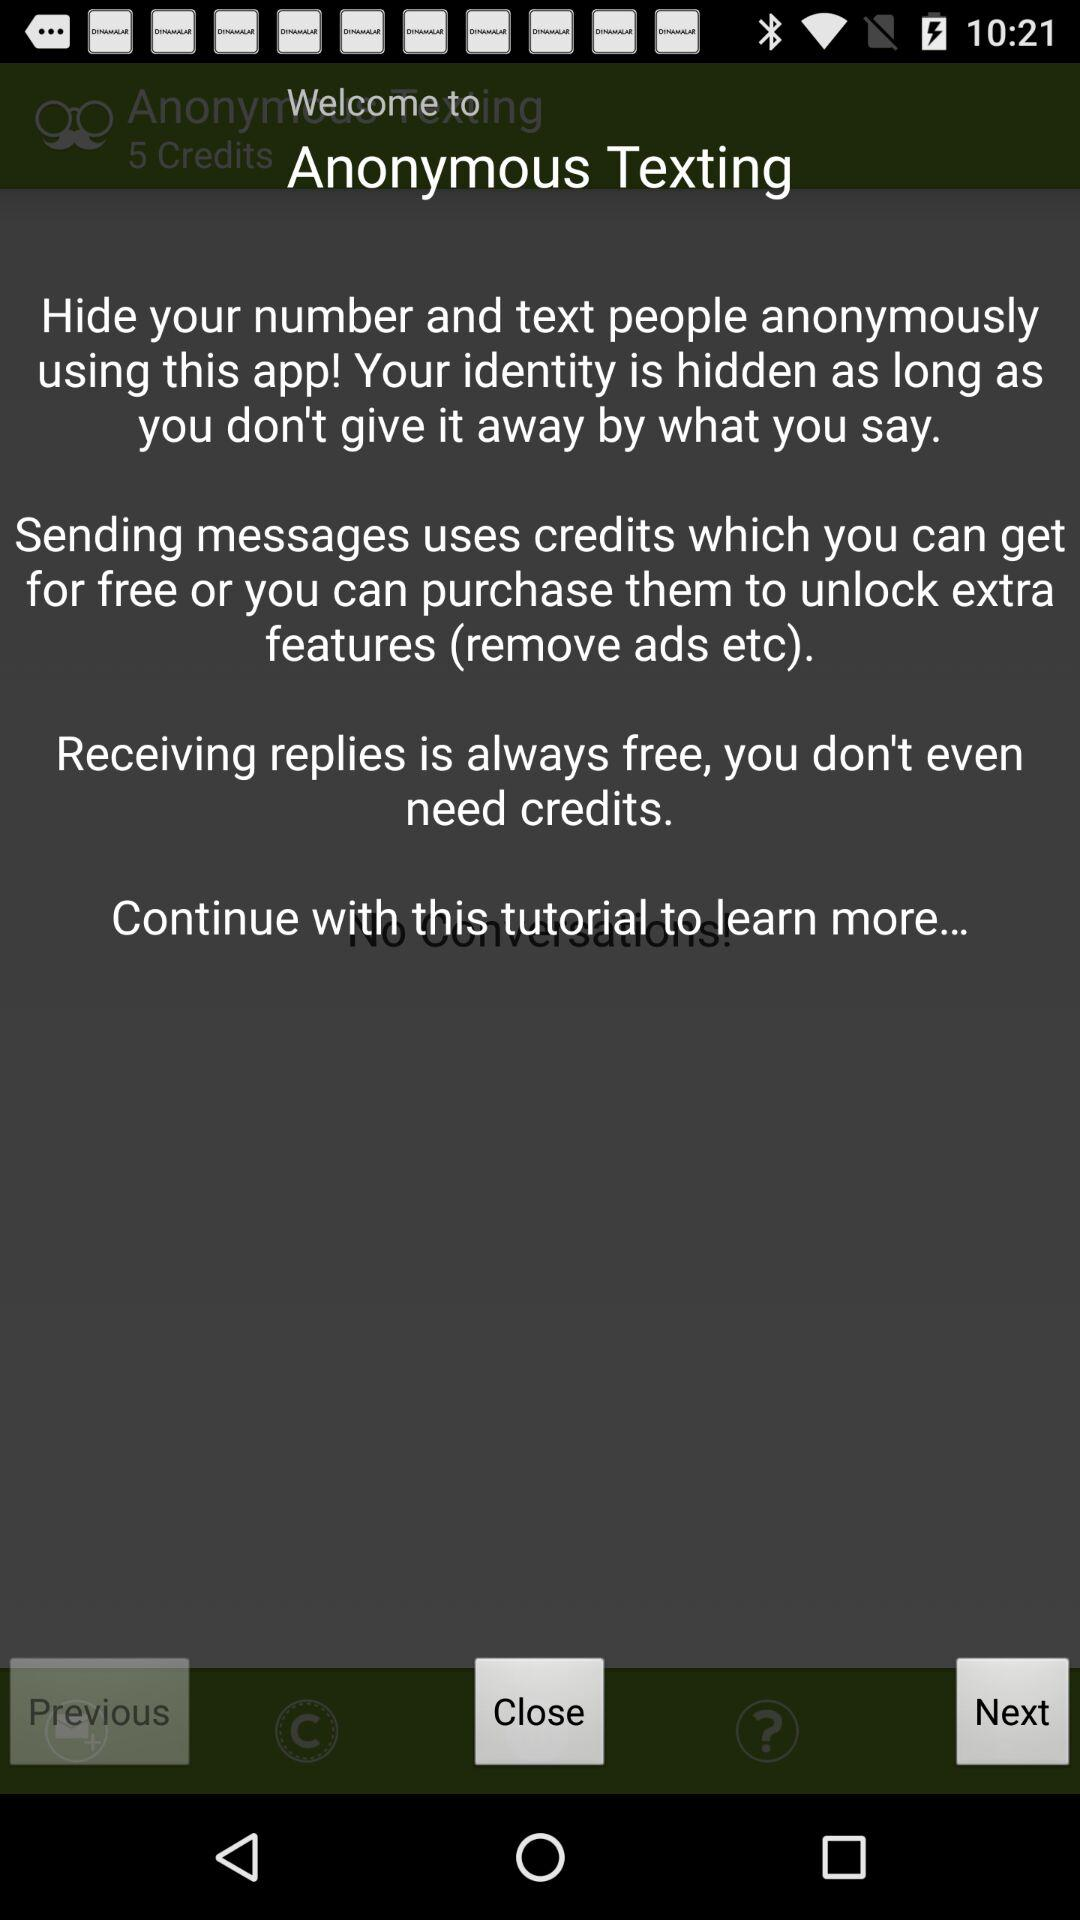What is the application name? The application name is "Anonymous Texting". 